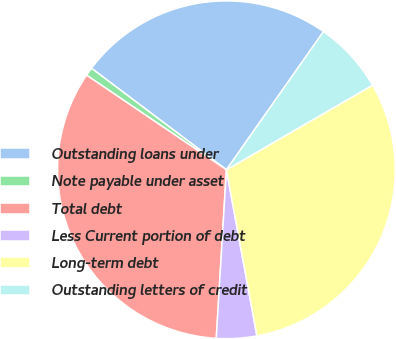<chart> <loc_0><loc_0><loc_500><loc_500><pie_chart><fcel>Outstanding loans under<fcel>Note payable under asset<fcel>Total debt<fcel>Less Current portion of debt<fcel>Long-term debt<fcel>Outstanding letters of credit<nl><fcel>24.48%<fcel>0.8%<fcel>33.51%<fcel>3.85%<fcel>30.46%<fcel>6.9%<nl></chart> 